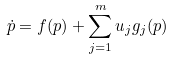Convert formula to latex. <formula><loc_0><loc_0><loc_500><loc_500>\dot { p } = f ( p ) + \sum _ { j = 1 } ^ { m } u _ { j } g _ { j } ( p )</formula> 